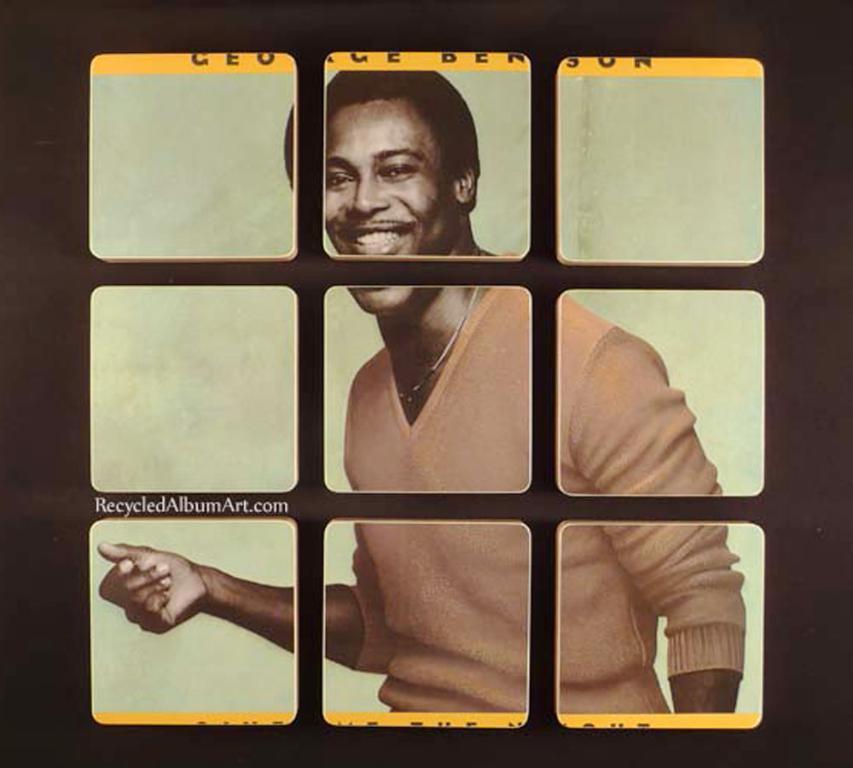Describe this image in one or two sentences. This picture describes about collarge images. 